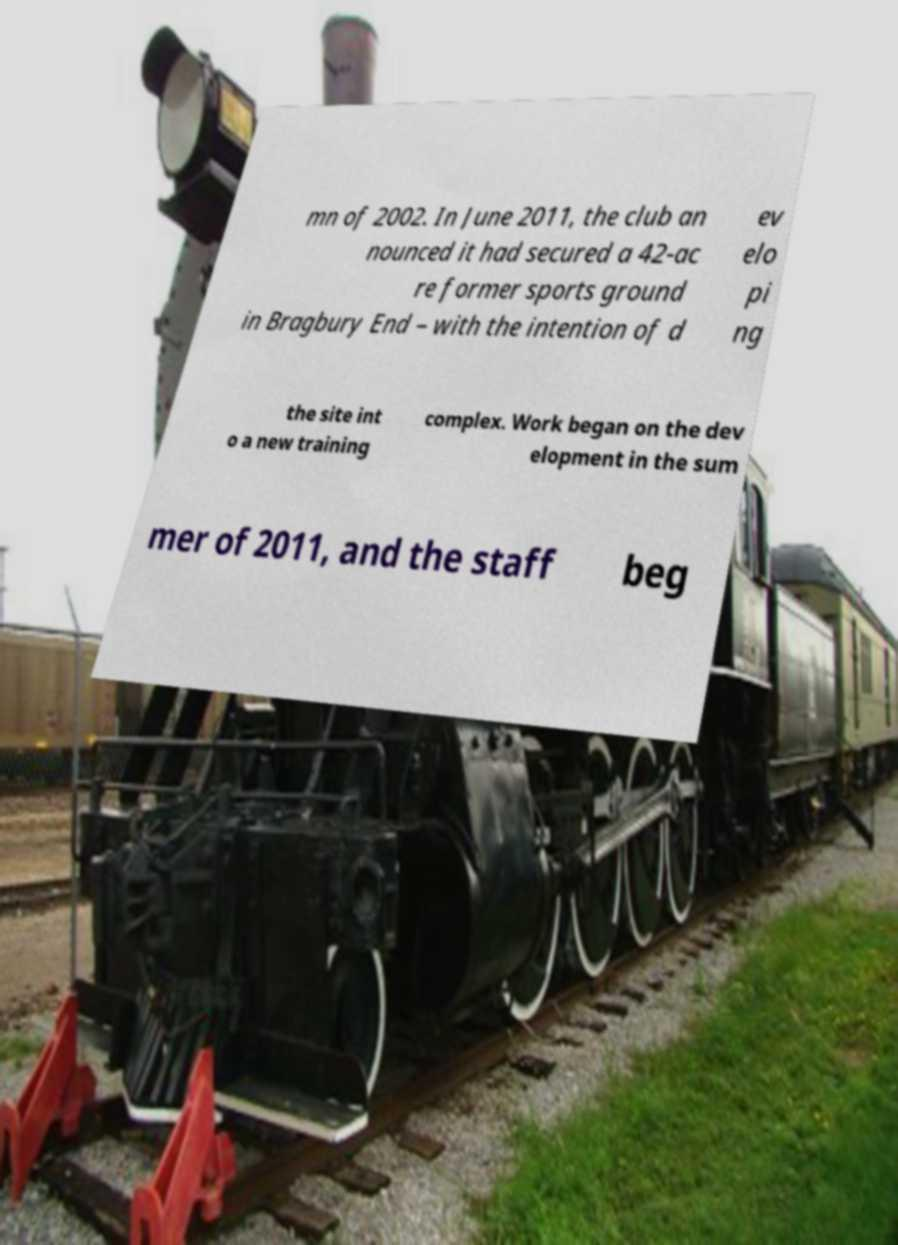Can you accurately transcribe the text from the provided image for me? mn of 2002. In June 2011, the club an nounced it had secured a 42-ac re former sports ground in Bragbury End – with the intention of d ev elo pi ng the site int o a new training complex. Work began on the dev elopment in the sum mer of 2011, and the staff beg 